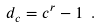<formula> <loc_0><loc_0><loc_500><loc_500>d _ { c } = c ^ { r } - 1 \ .</formula> 